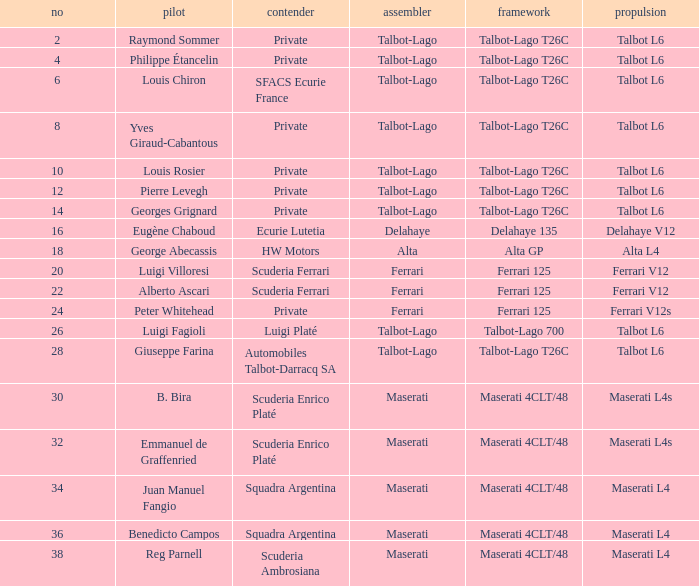Name the chassis for b. bira Maserati 4CLT/48. 